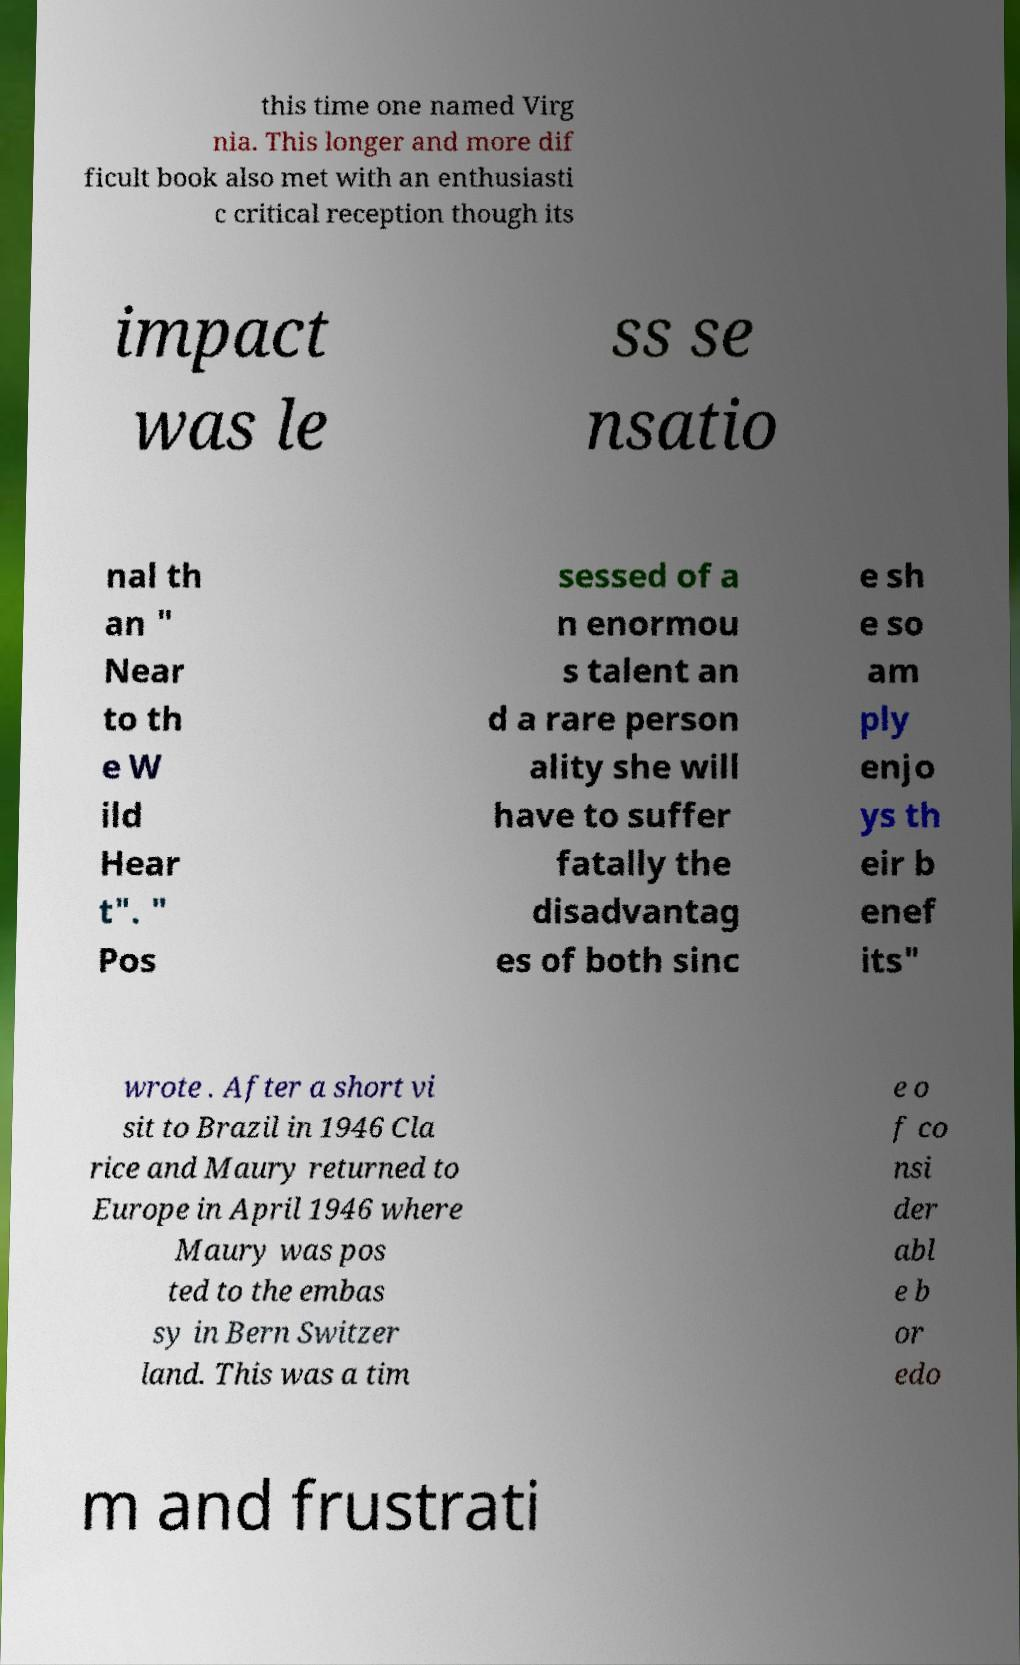Can you read and provide the text displayed in the image?This photo seems to have some interesting text. Can you extract and type it out for me? this time one named Virg nia. This longer and more dif ficult book also met with an enthusiasti c critical reception though its impact was le ss se nsatio nal th an " Near to th e W ild Hear t". " Pos sessed of a n enormou s talent an d a rare person ality she will have to suffer fatally the disadvantag es of both sinc e sh e so am ply enjo ys th eir b enef its" wrote . After a short vi sit to Brazil in 1946 Cla rice and Maury returned to Europe in April 1946 where Maury was pos ted to the embas sy in Bern Switzer land. This was a tim e o f co nsi der abl e b or edo m and frustrati 